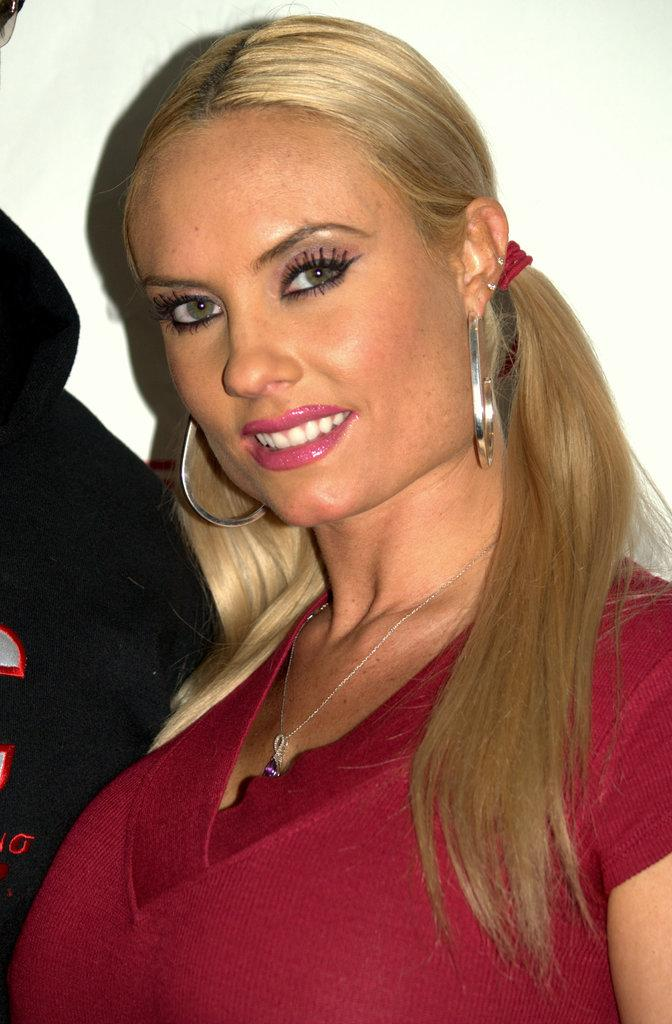Who is in the picture? There is a woman in the picture. What is the woman doing in the picture? The woman is standing in the picture. What expression does the woman have in the picture? The woman is smiling in the picture. What can be seen behind the woman in the image? There is a white surface in the backdrop of the image. What type of butter is being used to create the woman's smile in the image? There is no butter present in the image, and the woman's smile is a natural expression. 